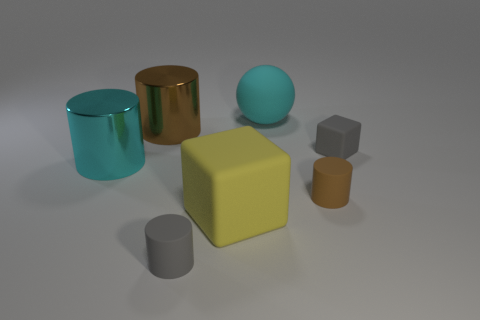How many other objects are the same size as the cyan sphere?
Give a very brief answer. 3. Is there anything else that is the same shape as the large cyan matte thing?
Your answer should be very brief. No. Are there the same number of large matte things that are on the right side of the small block and large purple rubber blocks?
Provide a succinct answer. Yes. How many small purple cubes are the same material as the large ball?
Ensure brevity in your answer.  0. What is the color of the large thing that is the same material as the big cyan ball?
Ensure brevity in your answer.  Yellow. Is the shape of the brown shiny object the same as the small brown rubber object?
Ensure brevity in your answer.  Yes. There is a gray object behind the tiny matte cylinder to the right of the gray cylinder; is there a cyan thing behind it?
Your response must be concise. Yes. What number of metal objects have the same color as the big matte sphere?
Your answer should be compact. 1. There is a cyan thing that is the same size as the cyan cylinder; what shape is it?
Your response must be concise. Sphere. There is a tiny brown rubber thing; are there any small rubber objects behind it?
Keep it short and to the point. Yes. 